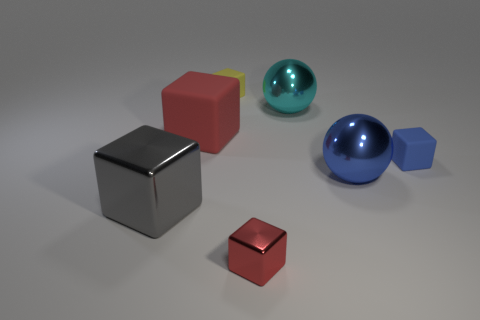Subtract all big red rubber cubes. How many cubes are left? 4 Add 2 metal balls. How many objects exist? 9 Subtract all blue cylinders. How many red cubes are left? 2 Subtract all red blocks. How many blocks are left? 3 Subtract 2 balls. How many balls are left? 0 Subtract all balls. How many objects are left? 5 Subtract all small red matte cylinders. Subtract all red blocks. How many objects are left? 5 Add 1 tiny cubes. How many tiny cubes are left? 4 Add 7 large brown cubes. How many large brown cubes exist? 7 Subtract 0 green cylinders. How many objects are left? 7 